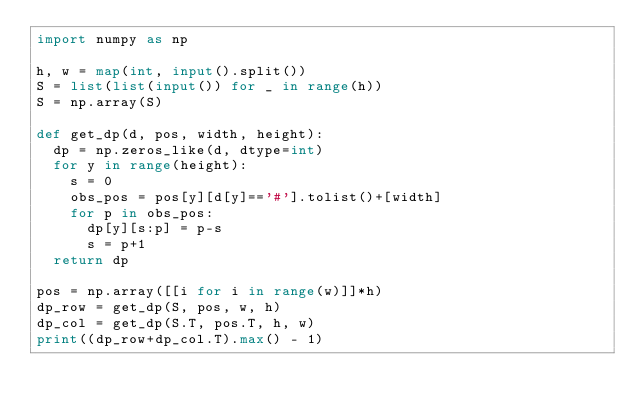Convert code to text. <code><loc_0><loc_0><loc_500><loc_500><_Python_>import numpy as np

h, w = map(int, input().split())
S = list(list(input()) for _ in range(h))
S = np.array(S)

def get_dp(d, pos, width, height):
  dp = np.zeros_like(d, dtype=int)
  for y in range(height):
    s = 0
    obs_pos = pos[y][d[y]=='#'].tolist()+[width]
    for p in obs_pos:
      dp[y][s:p] = p-s
      s = p+1
  return dp

pos = np.array([[i for i in range(w)]]*h)
dp_row = get_dp(S, pos, w, h)
dp_col = get_dp(S.T, pos.T, h, w)
print((dp_row+dp_col.T).max() - 1)</code> 